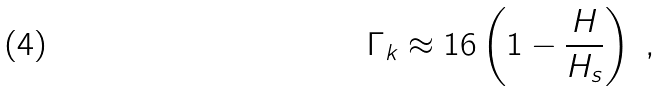<formula> <loc_0><loc_0><loc_500><loc_500>\Gamma _ { k } \approx 1 6 \left ( 1 - \frac { H } { H _ { s } } \right ) \ ,</formula> 